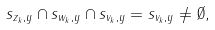<formula> <loc_0><loc_0><loc_500><loc_500>s _ { z _ { k } , y } \cap s _ { w _ { k } , y } \cap s _ { v _ { k } , y } = s _ { v _ { k } , y } \neq \emptyset ,</formula> 